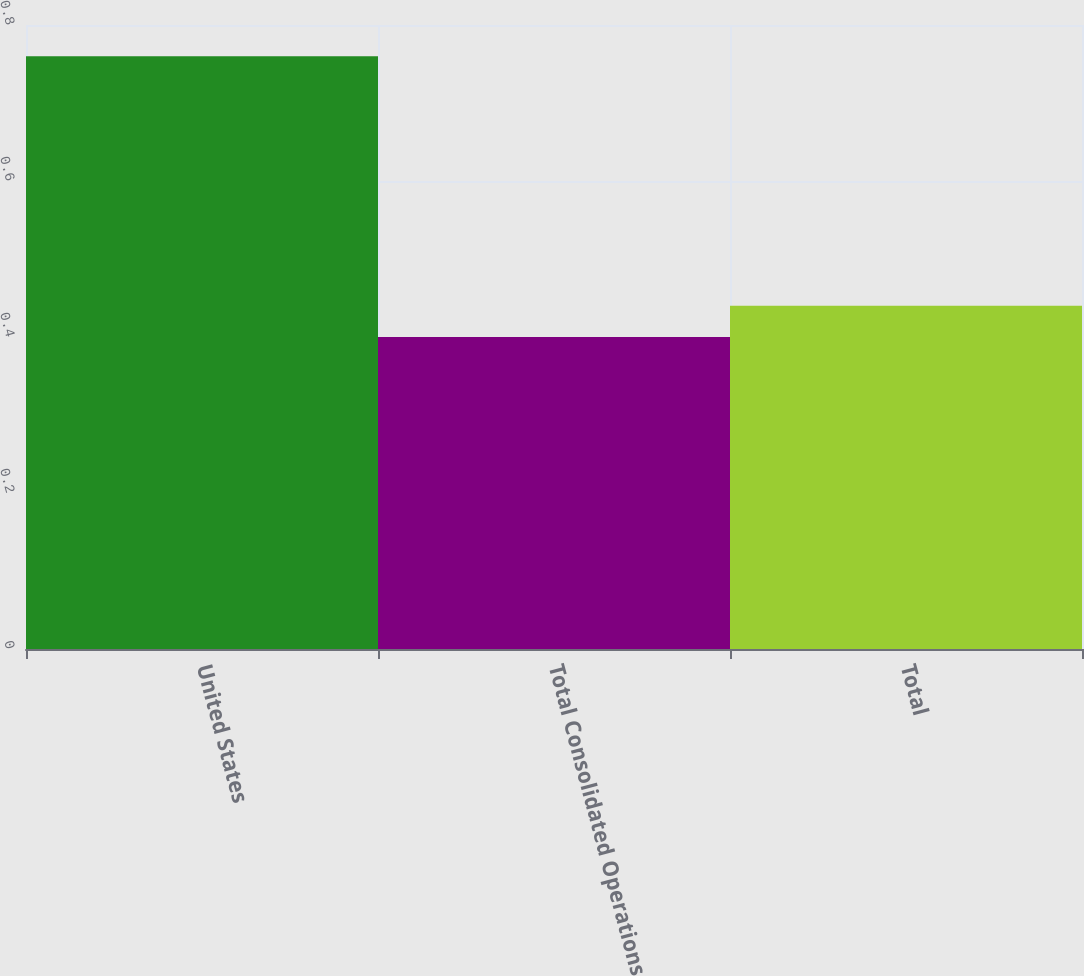Convert chart to OTSL. <chart><loc_0><loc_0><loc_500><loc_500><bar_chart><fcel>United States<fcel>Total Consolidated Operations<fcel>Total<nl><fcel>0.76<fcel>0.4<fcel>0.44<nl></chart> 